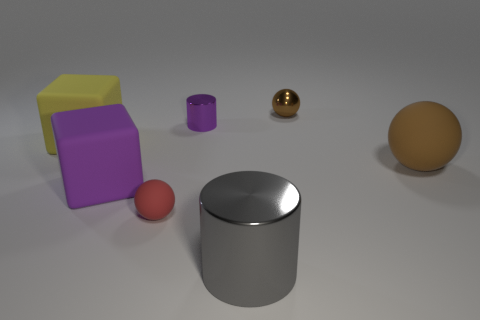Add 1 big brown rubber objects. How many objects exist? 8 Subtract all spheres. How many objects are left? 4 Subtract 2 brown balls. How many objects are left? 5 Subtract all red objects. Subtract all big purple rubber things. How many objects are left? 5 Add 5 big yellow rubber things. How many big yellow rubber things are left? 6 Add 1 gray cylinders. How many gray cylinders exist? 2 